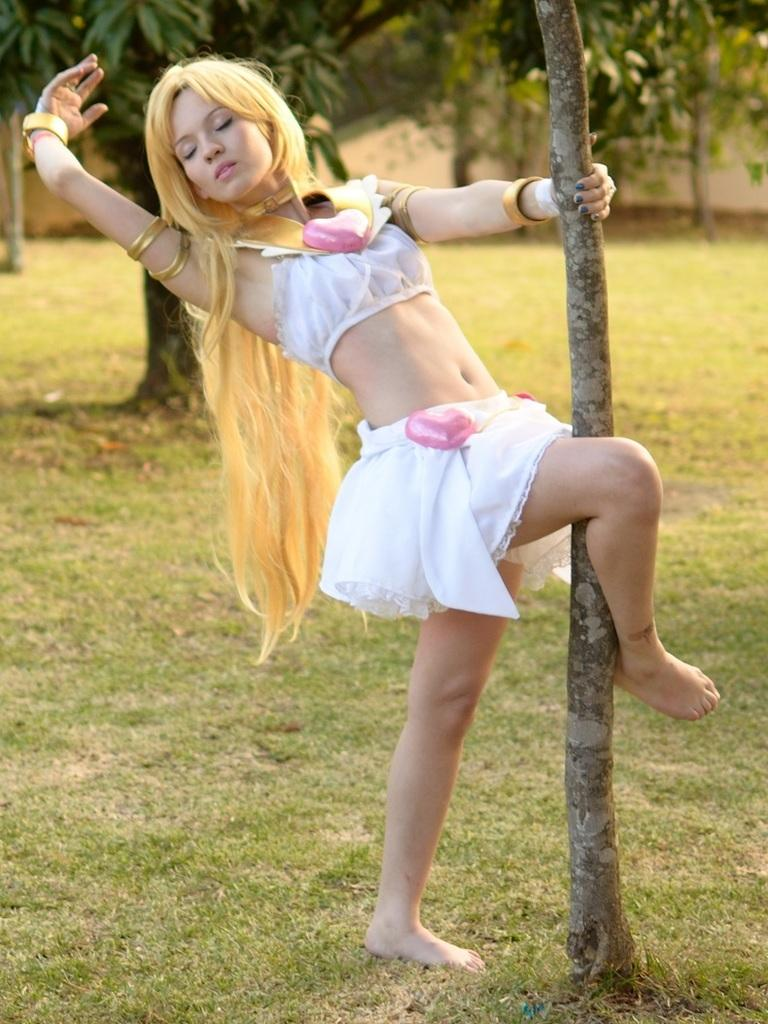Who is the main subject in the image? There is a lady in the center of the image. What can be seen in the background of the image? There are trees in the background of the image. What type of vegetation is at the bottom of the image? There is grass at the bottom of the image. How much does the baby weigh on the scale in the image? There is no baby or scale present in the image. What is the cause of the war depicted in the image? There is no war depicted in the image; it features a lady, trees, and grass. 